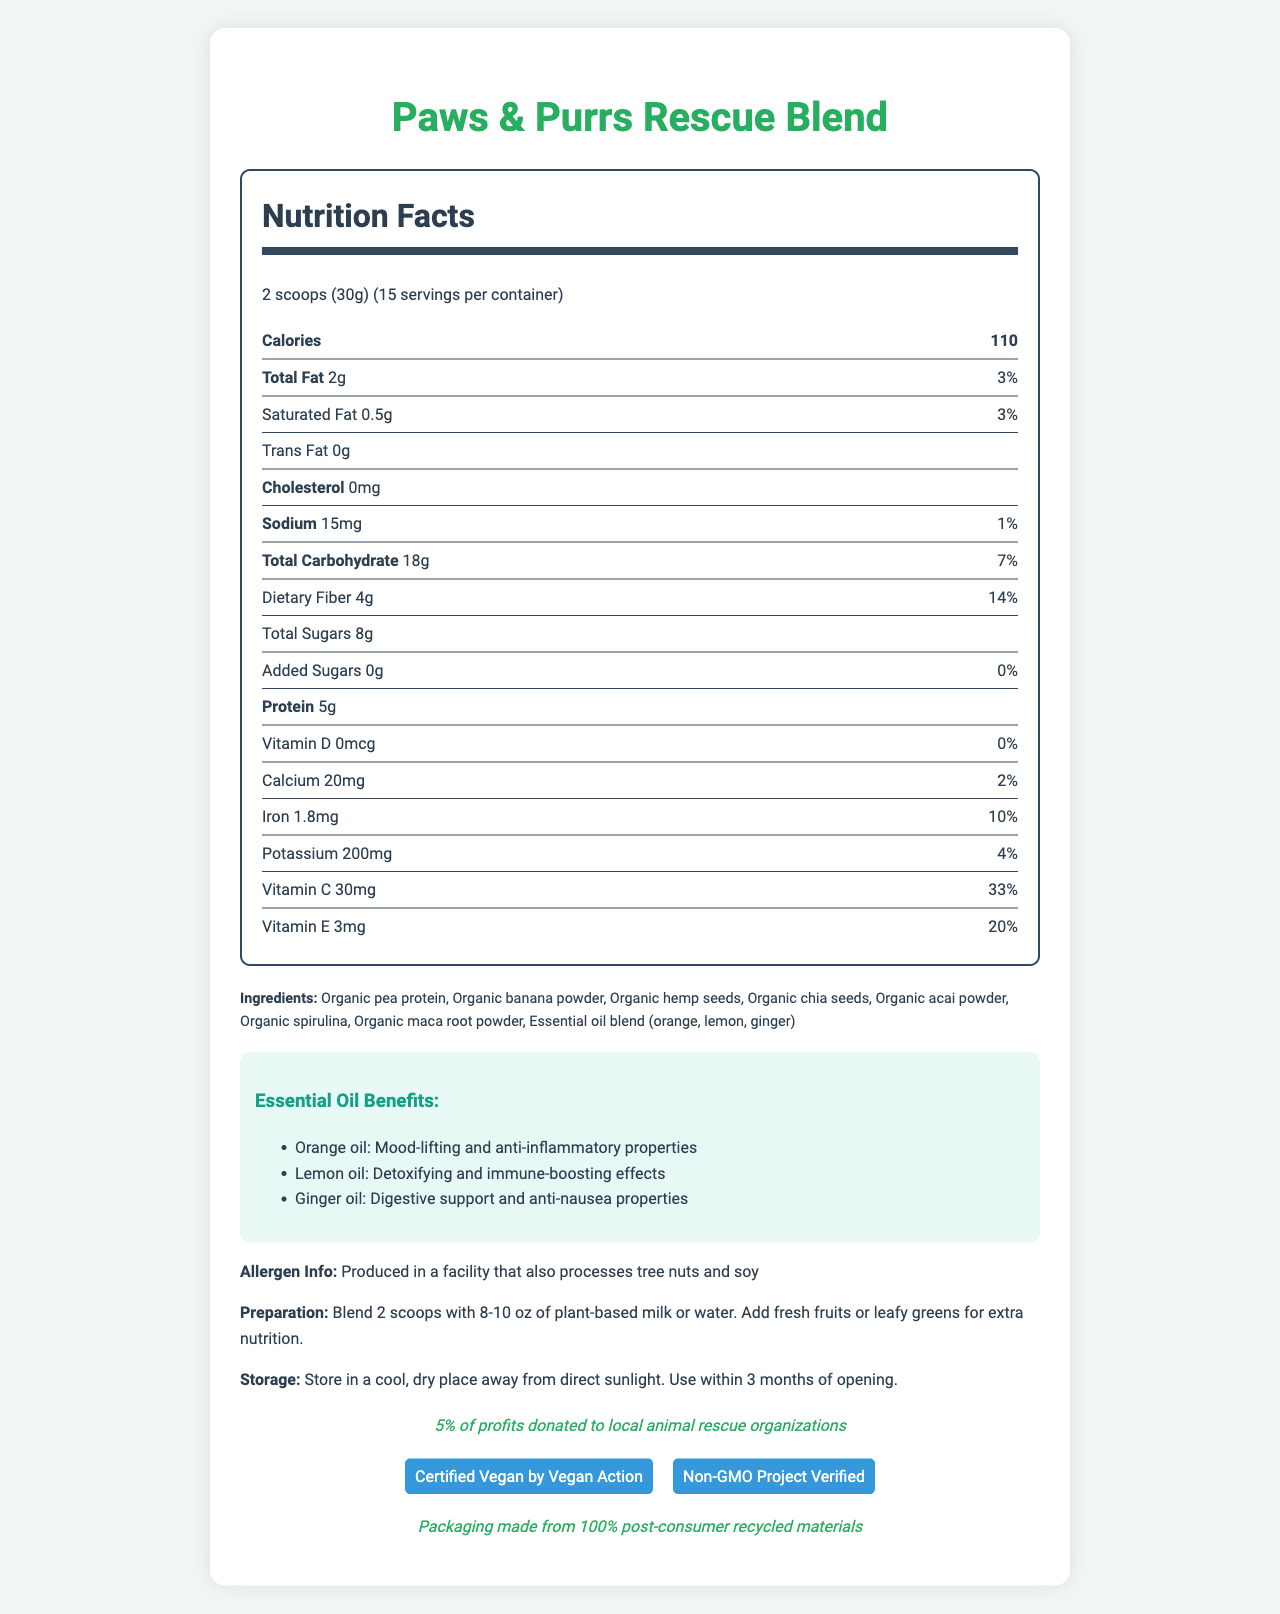how many servings are there per container? The document states that there are 15 servings per container.
Answer: 15 what is the serving size? The document specifies the serving size as 2 scoops (30g).
Answer: 2 scoops (30g) how many calories are in one serving? The document lists 110 calories per serving.
Answer: 110 what is the amount of protein per serving? The document shows that each serving contains 5g of protein.
Answer: 5g which vitamins are listed in the nutrition facts? According to the document, the vitamins listed are Vitamin D, Calcium, Iron, Potassium, Vitamin C, and Vitamin E.
Answer: Vitamin D, Calcium, Iron, Potassium, Vitamin C, Vitamin E which essential oils are included in the ingredient list? The essential oils included in the ingredient list are orange, lemon, and ginger.
Answer: Orange, Lemon, Ginger what is the daily value percentage for dietary fiber? The document states that the daily value percentage for dietary fiber is 14%.
Answer: 14% which dietary component has the highest daily value percentage? A. Dietary Fiber B. Vitamin C C. Calcium According to the document, Vitamin C has a daily value percentage of 33%, which is the highest among the listed options.
Answer: B is the product vegan? A. Yes B. No The document mentions that the product is "Certified Vegan by Vegan Action."
Answer: A is the product certified to be non-gmo? A. Yes B. No The document includes the "Non-GMO Project Verified" certification, indicating that the product is non-GMO.
Answer: A does the product contain any cholesterol? The document clearly states that the cholesterol amount is 0mg.
Answer: No is there any added sugar in the product? The document lists added sugars as 0g with 0% daily value.
Answer: No to which organizations does the product donate 5% of its profits? The ethical statement in the document states that 5% of profits are donated to local animal rescue organizations.
Answer: Local animal rescue organizations are there any allergens present in the product? The document includes a note stating that the product is produced in a facility that also processes tree nuts and soy, indicating potential allergen exposure.
Answer: Yes how should the product be stored? The storage instructions in the document advise storing the product in a cool, dry place away from direct sunlight and using it within 3 months of opening.
Answer: In a cool, dry place away from direct sunlight. Use within 3 months of opening. which essential oil is known for its detoxifying and immune-boosting effects? The benefits section states that lemon oil has detoxifying and immune-boosting effects.
Answer: Lemon oil describe the main purpose and features of the document The document includes comprehensive details about the product, such as nutrition facts, ingredient benefits, certifications, and ethical statements. It also offers instructions for preparation and storage, emphasizing the product's health benefits and ethical commitments.
Answer: The document provides detailed nutrition information, ingredients, and benefits of the "Paws & Purrs Rescue Blend" vegan smoothie mix. It highlights certifications and ethical contributions, such as being vegan-certified, non-GMO, and donating 5% of profits to animal rescue organizations. Essential oil benefits and preparation instructions are also included. what is the exact amount of each ingredient in the blend? The document lists the ingredients but does not provide the exact amount of each ingredient.
Answer: Cannot be determined 